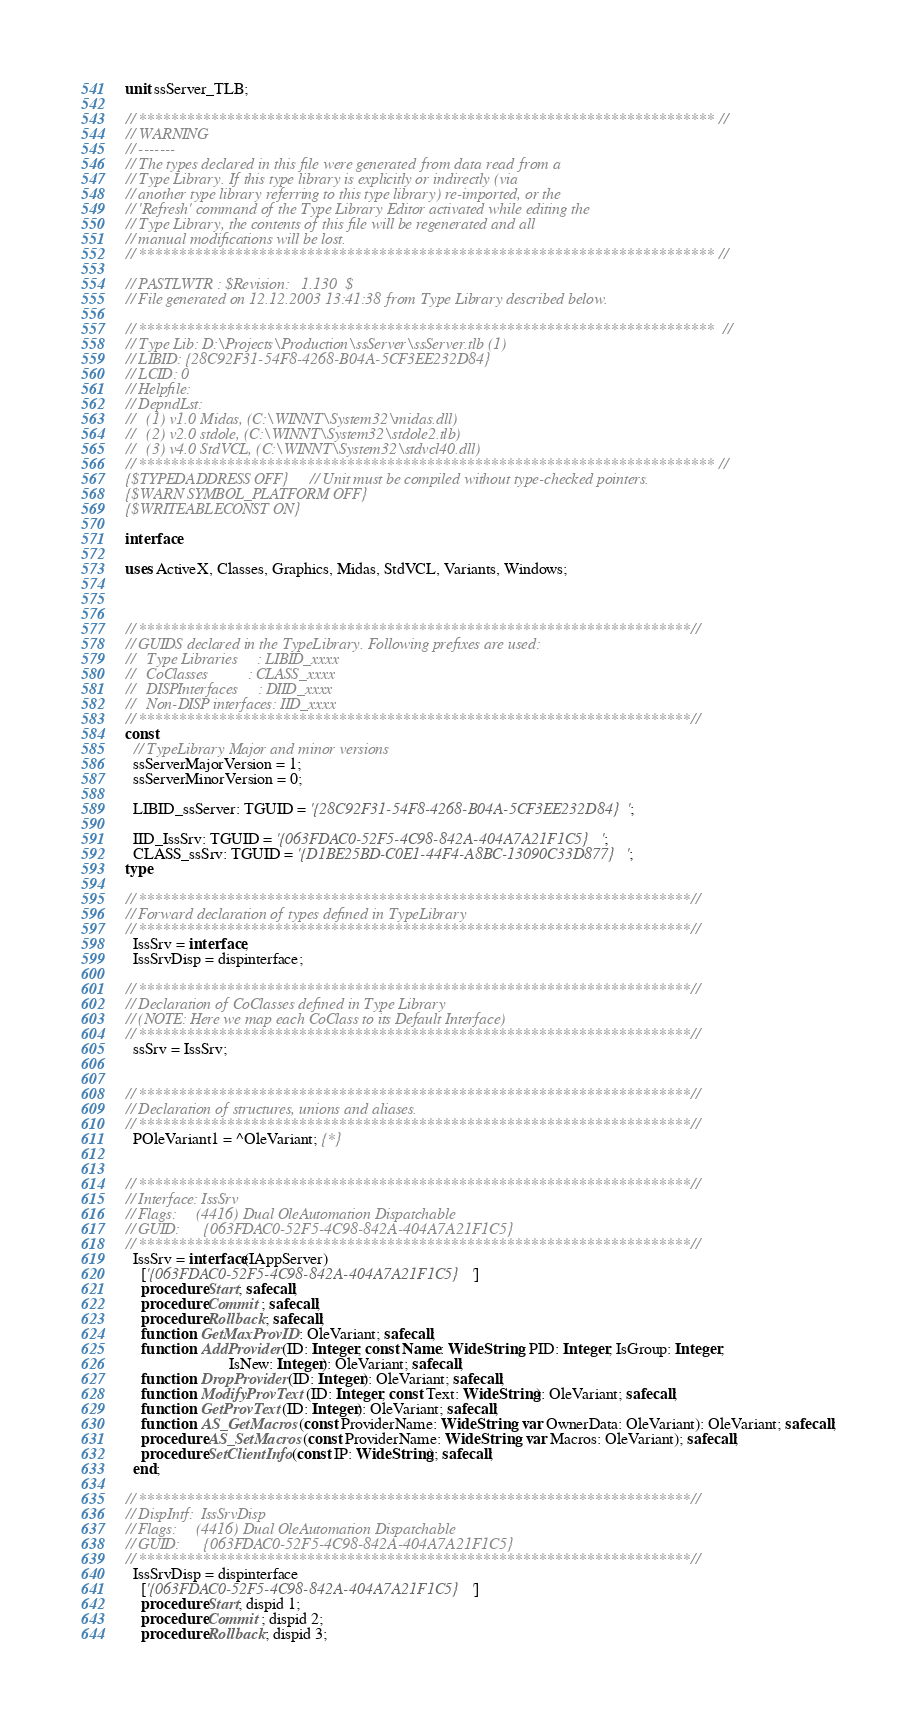<code> <loc_0><loc_0><loc_500><loc_500><_Pascal_>unit ssServer_TLB;

// ************************************************************************ //
// WARNING                                                                    
// -------                                                                    
// The types declared in this file were generated from data read from a       
// Type Library. If this type library is explicitly or indirectly (via        
// another type library referring to this type library) re-imported, or the   
// 'Refresh' command of the Type Library Editor activated while editing the   
// Type Library, the contents of this file will be regenerated and all        
// manual modifications will be lost.                                         
// ************************************************************************ //

// PASTLWTR : $Revision:   1.130  $
// File generated on 12.12.2003 13:41:38 from Type Library described below.

// ************************************************************************  //
// Type Lib: D:\Projects\Production\ssServer\ssServer.tlb (1)
// LIBID: {28C92F31-54F8-4268-B04A-5CF3EE232D84}
// LCID: 0
// Helpfile: 
// DepndLst: 
//   (1) v1.0 Midas, (C:\WINNT\System32\midas.dll)
//   (2) v2.0 stdole, (C:\WINNT\System32\stdole2.tlb)
//   (3) v4.0 StdVCL, (C:\WINNT\System32\stdvcl40.dll)
// ************************************************************************ //
{$TYPEDADDRESS OFF} // Unit must be compiled without type-checked pointers. 
{$WARN SYMBOL_PLATFORM OFF}
{$WRITEABLECONST ON}

interface

uses ActiveX, Classes, Graphics, Midas, StdVCL, Variants, Windows;
  


// *********************************************************************//
// GUIDS declared in the TypeLibrary. Following prefixes are used:        
//   Type Libraries     : LIBID_xxxx                                      
//   CoClasses          : CLASS_xxxx                                      
//   DISPInterfaces     : DIID_xxxx                                       
//   Non-DISP interfaces: IID_xxxx                                        
// *********************************************************************//
const
  // TypeLibrary Major and minor versions
  ssServerMajorVersion = 1;
  ssServerMinorVersion = 0;

  LIBID_ssServer: TGUID = '{28C92F31-54F8-4268-B04A-5CF3EE232D84}';

  IID_IssSrv: TGUID = '{063FDAC0-52F5-4C98-842A-404A7A21F1C5}';
  CLASS_ssSrv: TGUID = '{D1BE25BD-C0E1-44F4-A8BC-13090C33D877}';
type

// *********************************************************************//
// Forward declaration of types defined in TypeLibrary                    
// *********************************************************************//
  IssSrv = interface;
  IssSrvDisp = dispinterface;

// *********************************************************************//
// Declaration of CoClasses defined in Type Library                       
// (NOTE: Here we map each CoClass to its Default Interface)              
// *********************************************************************//
  ssSrv = IssSrv;


// *********************************************************************//
// Declaration of structures, unions and aliases.                         
// *********************************************************************//
  POleVariant1 = ^OleVariant; {*}


// *********************************************************************//
// Interface: IssSrv
// Flags:     (4416) Dual OleAutomation Dispatchable
// GUID:      {063FDAC0-52F5-4C98-842A-404A7A21F1C5}
// *********************************************************************//
  IssSrv = interface(IAppServer)
    ['{063FDAC0-52F5-4C98-842A-404A7A21F1C5}']
    procedure Start; safecall;
    procedure Commit; safecall;
    procedure Rollback; safecall;
    function  GetMaxProvID: OleVariant; safecall;
    function  AddProvider(ID: Integer; const Name: WideString; PID: Integer; IsGroup: Integer; 
                          IsNew: Integer): OleVariant; safecall;
    function  DropProvider(ID: Integer): OleVariant; safecall;
    function  ModifyProvText(ID: Integer; const Text: WideString): OleVariant; safecall;
    function  GetProvText(ID: Integer): OleVariant; safecall;
    function  AS_GetMacros(const ProviderName: WideString; var OwnerData: OleVariant): OleVariant; safecall;
    procedure AS_SetMacros(const ProviderName: WideString; var Macros: OleVariant); safecall;
    procedure SetClientInfo(const IP: WideString); safecall;
  end;

// *********************************************************************//
// DispIntf:  IssSrvDisp
// Flags:     (4416) Dual OleAutomation Dispatchable
// GUID:      {063FDAC0-52F5-4C98-842A-404A7A21F1C5}
// *********************************************************************//
  IssSrvDisp = dispinterface
    ['{063FDAC0-52F5-4C98-842A-404A7A21F1C5}']
    procedure Start; dispid 1;
    procedure Commit; dispid 2;
    procedure Rollback; dispid 3;</code> 